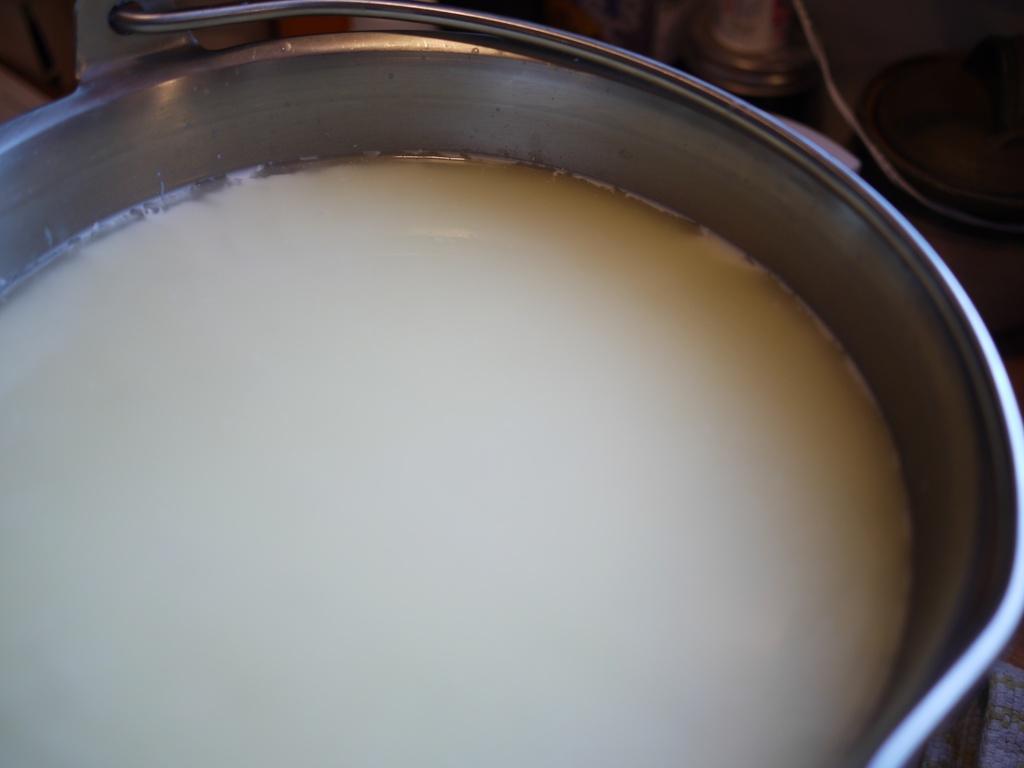Please provide a concise description of this image. In this picture we can see a steel bucket, in the bucket there is a white color liquid. At the top it is not clear. 